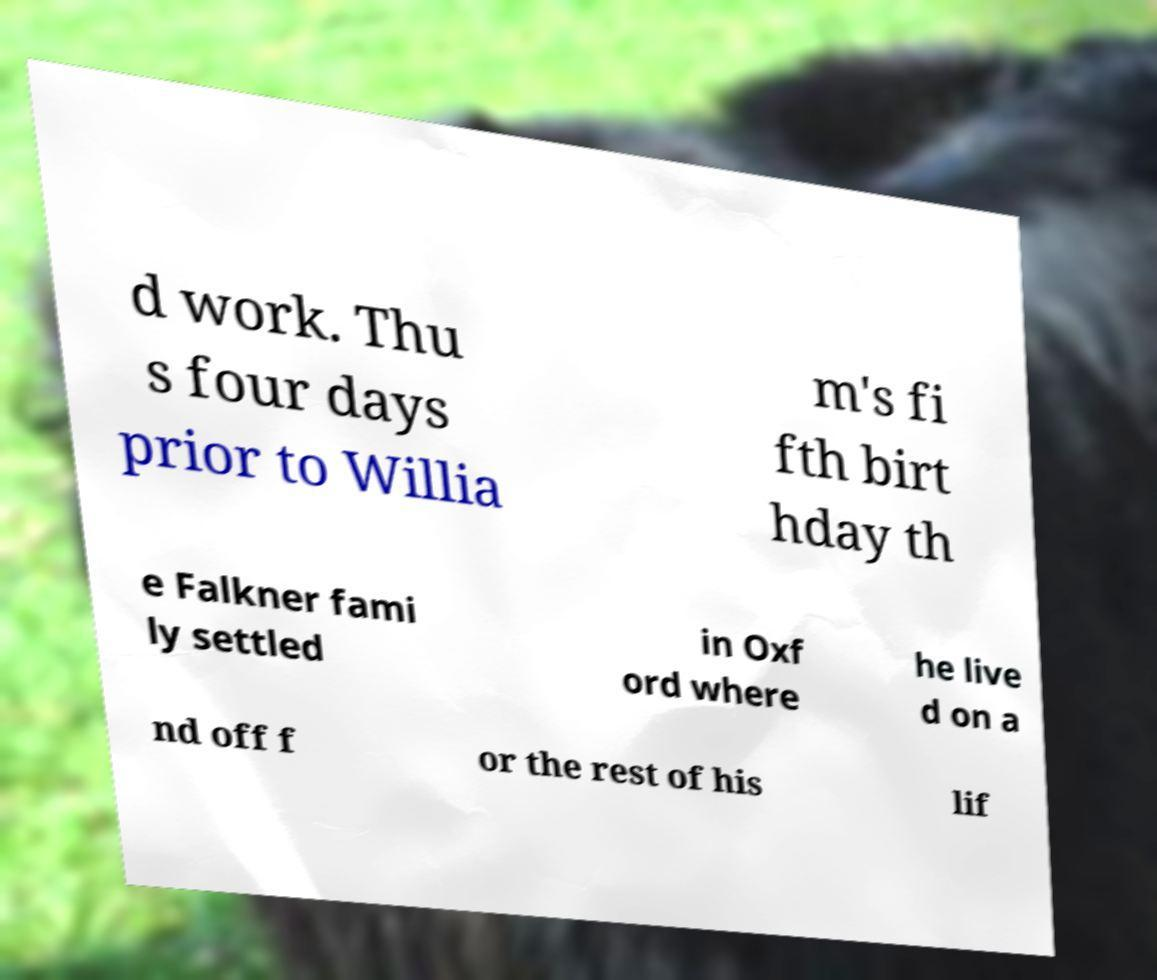Could you assist in decoding the text presented in this image and type it out clearly? d work. Thu s four days prior to Willia m's fi fth birt hday th e Falkner fami ly settled in Oxf ord where he live d on a nd off f or the rest of his lif 